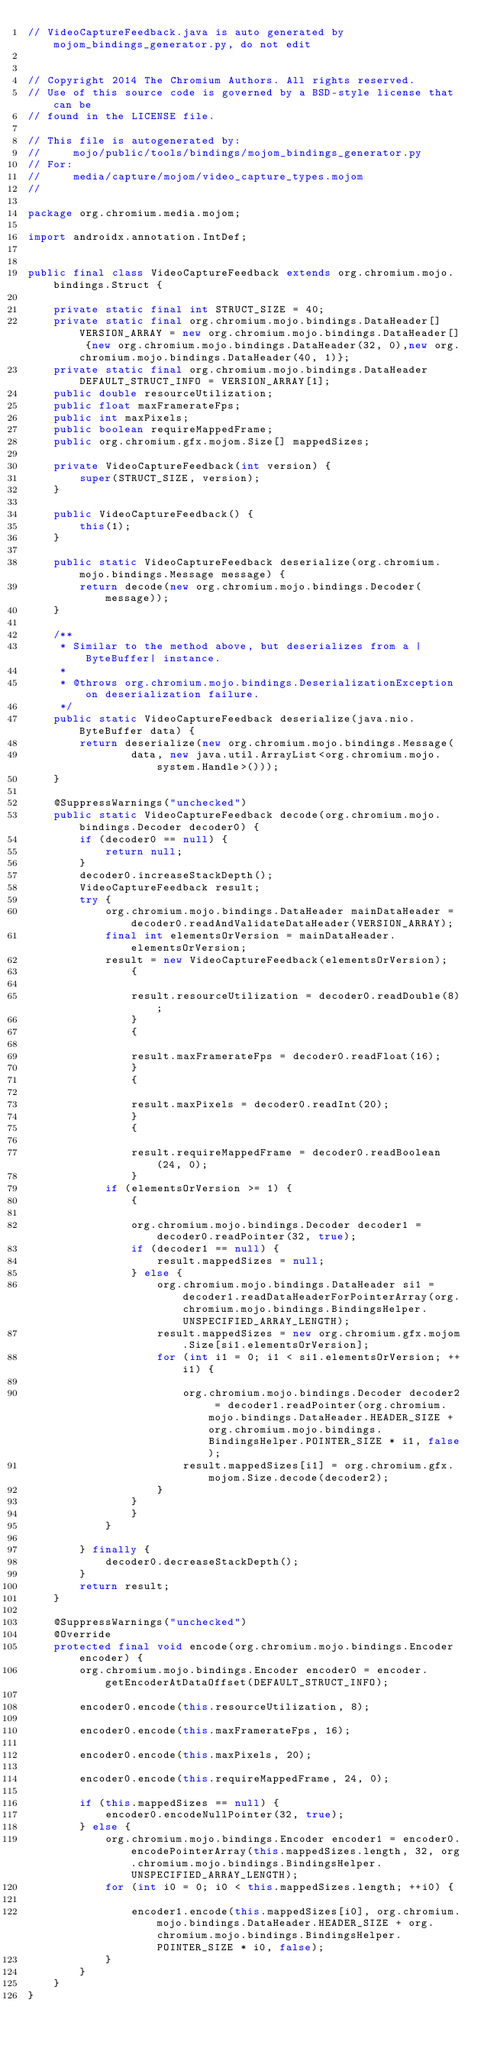<code> <loc_0><loc_0><loc_500><loc_500><_Java_>// VideoCaptureFeedback.java is auto generated by mojom_bindings_generator.py, do not edit


// Copyright 2014 The Chromium Authors. All rights reserved.
// Use of this source code is governed by a BSD-style license that can be
// found in the LICENSE file.

// This file is autogenerated by:
//     mojo/public/tools/bindings/mojom_bindings_generator.py
// For:
//     media/capture/mojom/video_capture_types.mojom
//

package org.chromium.media.mojom;

import androidx.annotation.IntDef;


public final class VideoCaptureFeedback extends org.chromium.mojo.bindings.Struct {

    private static final int STRUCT_SIZE = 40;
    private static final org.chromium.mojo.bindings.DataHeader[] VERSION_ARRAY = new org.chromium.mojo.bindings.DataHeader[] {new org.chromium.mojo.bindings.DataHeader(32, 0),new org.chromium.mojo.bindings.DataHeader(40, 1)};
    private static final org.chromium.mojo.bindings.DataHeader DEFAULT_STRUCT_INFO = VERSION_ARRAY[1];
    public double resourceUtilization;
    public float maxFramerateFps;
    public int maxPixels;
    public boolean requireMappedFrame;
    public org.chromium.gfx.mojom.Size[] mappedSizes;

    private VideoCaptureFeedback(int version) {
        super(STRUCT_SIZE, version);
    }

    public VideoCaptureFeedback() {
        this(1);
    }

    public static VideoCaptureFeedback deserialize(org.chromium.mojo.bindings.Message message) {
        return decode(new org.chromium.mojo.bindings.Decoder(message));
    }

    /**
     * Similar to the method above, but deserializes from a |ByteBuffer| instance.
     *
     * @throws org.chromium.mojo.bindings.DeserializationException on deserialization failure.
     */
    public static VideoCaptureFeedback deserialize(java.nio.ByteBuffer data) {
        return deserialize(new org.chromium.mojo.bindings.Message(
                data, new java.util.ArrayList<org.chromium.mojo.system.Handle>()));
    }

    @SuppressWarnings("unchecked")
    public static VideoCaptureFeedback decode(org.chromium.mojo.bindings.Decoder decoder0) {
        if (decoder0 == null) {
            return null;
        }
        decoder0.increaseStackDepth();
        VideoCaptureFeedback result;
        try {
            org.chromium.mojo.bindings.DataHeader mainDataHeader = decoder0.readAndValidateDataHeader(VERSION_ARRAY);
            final int elementsOrVersion = mainDataHeader.elementsOrVersion;
            result = new VideoCaptureFeedback(elementsOrVersion);
                {
                    
                result.resourceUtilization = decoder0.readDouble(8);
                }
                {
                    
                result.maxFramerateFps = decoder0.readFloat(16);
                }
                {
                    
                result.maxPixels = decoder0.readInt(20);
                }
                {
                    
                result.requireMappedFrame = decoder0.readBoolean(24, 0);
                }
            if (elementsOrVersion >= 1) {
                {
                    
                org.chromium.mojo.bindings.Decoder decoder1 = decoder0.readPointer(32, true);
                if (decoder1 == null) {
                    result.mappedSizes = null;
                } else {
                    org.chromium.mojo.bindings.DataHeader si1 = decoder1.readDataHeaderForPointerArray(org.chromium.mojo.bindings.BindingsHelper.UNSPECIFIED_ARRAY_LENGTH);
                    result.mappedSizes = new org.chromium.gfx.mojom.Size[si1.elementsOrVersion];
                    for (int i1 = 0; i1 < si1.elementsOrVersion; ++i1) {
                        
                        org.chromium.mojo.bindings.Decoder decoder2 = decoder1.readPointer(org.chromium.mojo.bindings.DataHeader.HEADER_SIZE + org.chromium.mojo.bindings.BindingsHelper.POINTER_SIZE * i1, false);
                        result.mappedSizes[i1] = org.chromium.gfx.mojom.Size.decode(decoder2);
                    }
                }
                }
            }

        } finally {
            decoder0.decreaseStackDepth();
        }
        return result;
    }

    @SuppressWarnings("unchecked")
    @Override
    protected final void encode(org.chromium.mojo.bindings.Encoder encoder) {
        org.chromium.mojo.bindings.Encoder encoder0 = encoder.getEncoderAtDataOffset(DEFAULT_STRUCT_INFO);
        
        encoder0.encode(this.resourceUtilization, 8);
        
        encoder0.encode(this.maxFramerateFps, 16);
        
        encoder0.encode(this.maxPixels, 20);
        
        encoder0.encode(this.requireMappedFrame, 24, 0);
        
        if (this.mappedSizes == null) {
            encoder0.encodeNullPointer(32, true);
        } else {
            org.chromium.mojo.bindings.Encoder encoder1 = encoder0.encodePointerArray(this.mappedSizes.length, 32, org.chromium.mojo.bindings.BindingsHelper.UNSPECIFIED_ARRAY_LENGTH);
            for (int i0 = 0; i0 < this.mappedSizes.length; ++i0) {
                
                encoder1.encode(this.mappedSizes[i0], org.chromium.mojo.bindings.DataHeader.HEADER_SIZE + org.chromium.mojo.bindings.BindingsHelper.POINTER_SIZE * i0, false);
            }
        }
    }
}</code> 